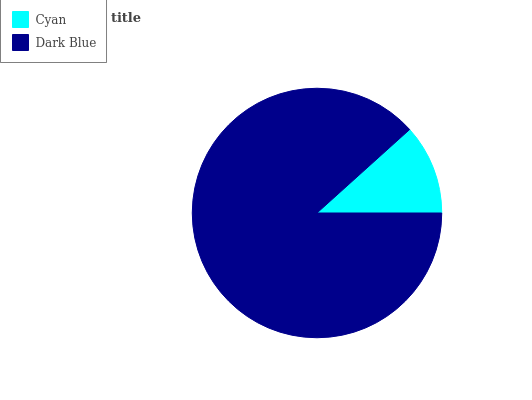Is Cyan the minimum?
Answer yes or no. Yes. Is Dark Blue the maximum?
Answer yes or no. Yes. Is Dark Blue the minimum?
Answer yes or no. No. Is Dark Blue greater than Cyan?
Answer yes or no. Yes. Is Cyan less than Dark Blue?
Answer yes or no. Yes. Is Cyan greater than Dark Blue?
Answer yes or no. No. Is Dark Blue less than Cyan?
Answer yes or no. No. Is Dark Blue the high median?
Answer yes or no. Yes. Is Cyan the low median?
Answer yes or no. Yes. Is Cyan the high median?
Answer yes or no. No. Is Dark Blue the low median?
Answer yes or no. No. 